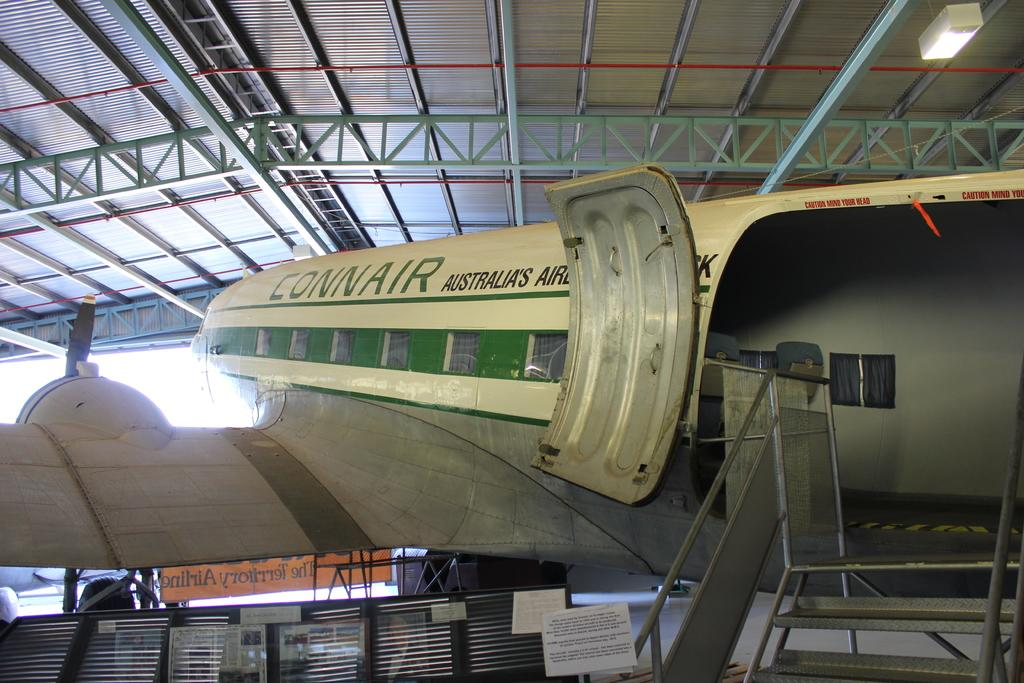<image>
Summarize the visual content of the image. A Connair plane has its doors open in a hangar. 